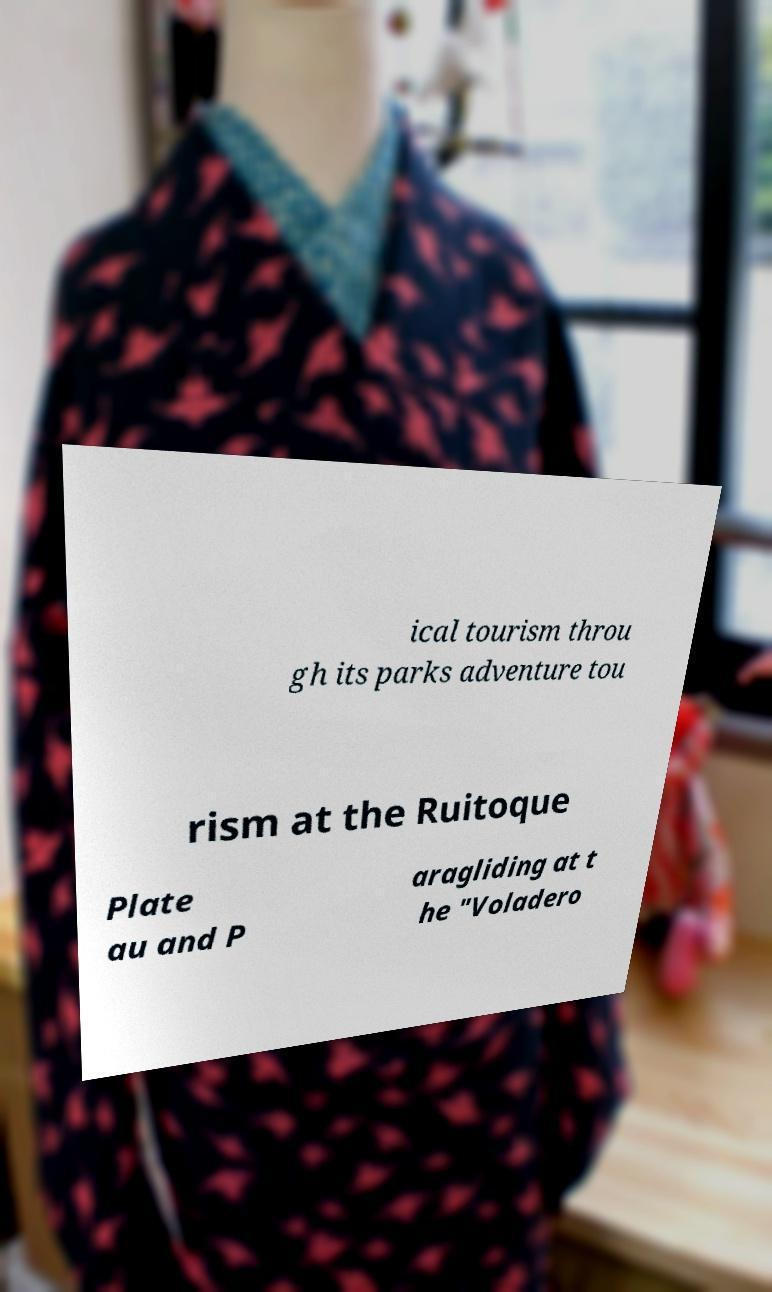For documentation purposes, I need the text within this image transcribed. Could you provide that? ical tourism throu gh its parks adventure tou rism at the Ruitoque Plate au and P aragliding at t he "Voladero 